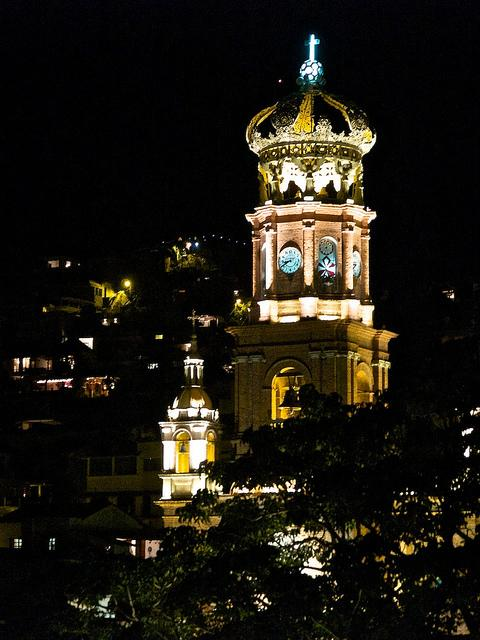What is on the top of the building?

Choices:
A) cross
B) human
C) weathervane
D) bird cross 